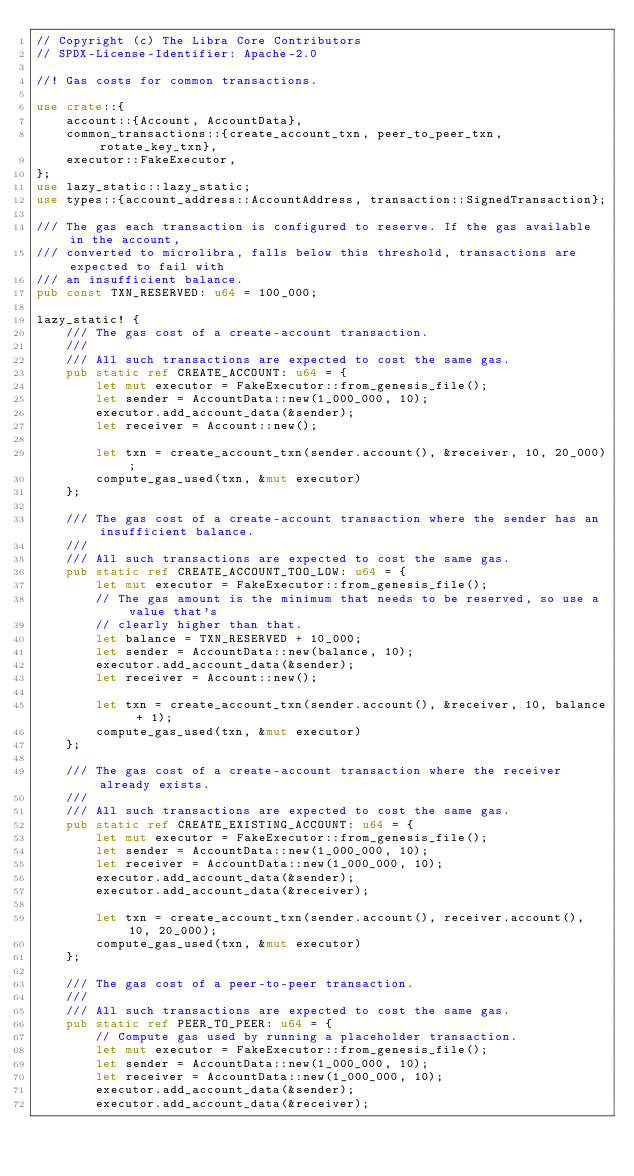Convert code to text. <code><loc_0><loc_0><loc_500><loc_500><_Rust_>// Copyright (c) The Libra Core Contributors
// SPDX-License-Identifier: Apache-2.0

//! Gas costs for common transactions.

use crate::{
    account::{Account, AccountData},
    common_transactions::{create_account_txn, peer_to_peer_txn, rotate_key_txn},
    executor::FakeExecutor,
};
use lazy_static::lazy_static;
use types::{account_address::AccountAddress, transaction::SignedTransaction};

/// The gas each transaction is configured to reserve. If the gas available in the account,
/// converted to microlibra, falls below this threshold, transactions are expected to fail with
/// an insufficient balance.
pub const TXN_RESERVED: u64 = 100_000;

lazy_static! {
    /// The gas cost of a create-account transaction.
    ///
    /// All such transactions are expected to cost the same gas.
    pub static ref CREATE_ACCOUNT: u64 = {
        let mut executor = FakeExecutor::from_genesis_file();
        let sender = AccountData::new(1_000_000, 10);
        executor.add_account_data(&sender);
        let receiver = Account::new();

        let txn = create_account_txn(sender.account(), &receiver, 10, 20_000);
        compute_gas_used(txn, &mut executor)
    };

    /// The gas cost of a create-account transaction where the sender has an insufficient balance.
    ///
    /// All such transactions are expected to cost the same gas.
    pub static ref CREATE_ACCOUNT_TOO_LOW: u64 = {
        let mut executor = FakeExecutor::from_genesis_file();
        // The gas amount is the minimum that needs to be reserved, so use a value that's
        // clearly higher than that.
        let balance = TXN_RESERVED + 10_000;
        let sender = AccountData::new(balance, 10);
        executor.add_account_data(&sender);
        let receiver = Account::new();

        let txn = create_account_txn(sender.account(), &receiver, 10, balance + 1);
        compute_gas_used(txn, &mut executor)
    };

    /// The gas cost of a create-account transaction where the receiver already exists.
    ///
    /// All such transactions are expected to cost the same gas.
    pub static ref CREATE_EXISTING_ACCOUNT: u64 = {
        let mut executor = FakeExecutor::from_genesis_file();
        let sender = AccountData::new(1_000_000, 10);
        let receiver = AccountData::new(1_000_000, 10);
        executor.add_account_data(&sender);
        executor.add_account_data(&receiver);

        let txn = create_account_txn(sender.account(), receiver.account(), 10, 20_000);
        compute_gas_used(txn, &mut executor)
    };

    /// The gas cost of a peer-to-peer transaction.
    ///
    /// All such transactions are expected to cost the same gas.
    pub static ref PEER_TO_PEER: u64 = {
        // Compute gas used by running a placeholder transaction.
        let mut executor = FakeExecutor::from_genesis_file();
        let sender = AccountData::new(1_000_000, 10);
        let receiver = AccountData::new(1_000_000, 10);
        executor.add_account_data(&sender);
        executor.add_account_data(&receiver);
</code> 